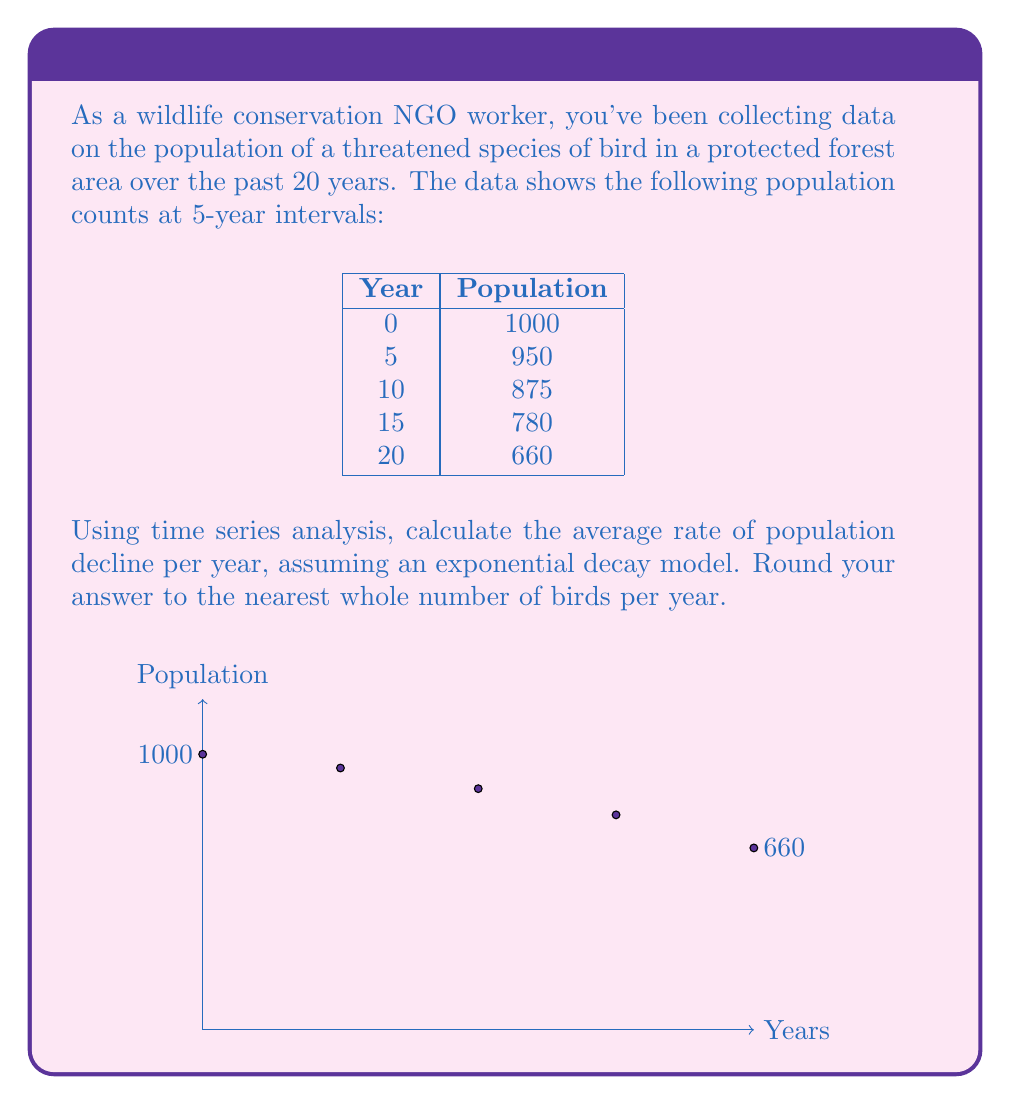Help me with this question. To solve this problem, we'll use the exponential decay model:

$$P(t) = P_0 e^{-rt}$$

Where:
$P(t)$ is the population at time $t$
$P_0$ is the initial population
$r$ is the rate of decline
$t$ is the time

Step 1: Set up the equation using the initial and final data points:
$$660 = 1000 e^{-r(20)}$$

Step 2: Take the natural logarithm of both sides:
$$\ln(660) = \ln(1000) + \ln(e^{-r(20)})$$
$$\ln(660) = \ln(1000) - 20r$$

Step 3: Solve for $r$:
$$20r = \ln(1000) - \ln(660)$$
$$r = \frac{\ln(1000) - \ln(660)}{20}$$
$$r \approx 0.0208$$

Step 4: Calculate the average number of birds declining per year:
Average decline = Initial population × (1 - $e^{-r}$)
$$1000 \times (1 - e^{-0.0208}) \approx 20.58$$

Step 5: Round to the nearest whole number:
21 birds per year
Answer: 21 birds per year 